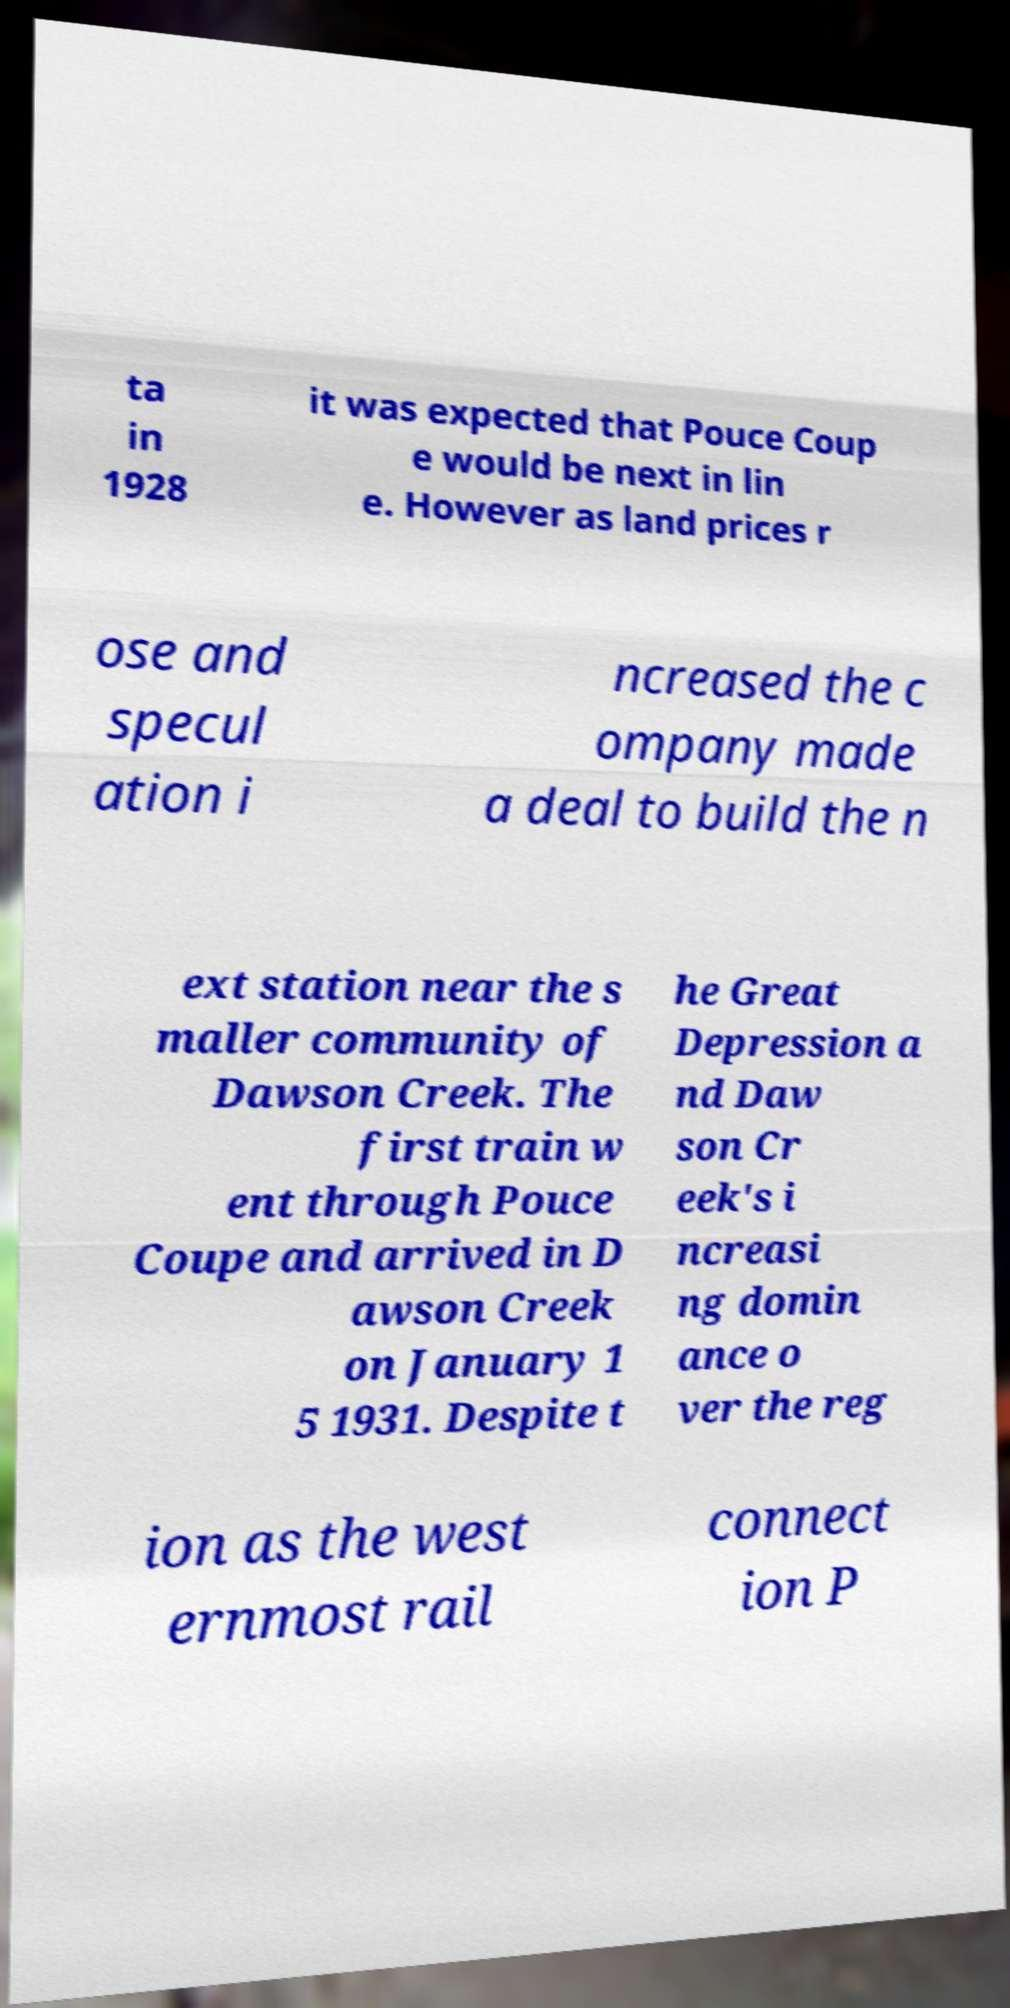There's text embedded in this image that I need extracted. Can you transcribe it verbatim? ta in 1928 it was expected that Pouce Coup e would be next in lin e. However as land prices r ose and specul ation i ncreased the c ompany made a deal to build the n ext station near the s maller community of Dawson Creek. The first train w ent through Pouce Coupe and arrived in D awson Creek on January 1 5 1931. Despite t he Great Depression a nd Daw son Cr eek's i ncreasi ng domin ance o ver the reg ion as the west ernmost rail connect ion P 